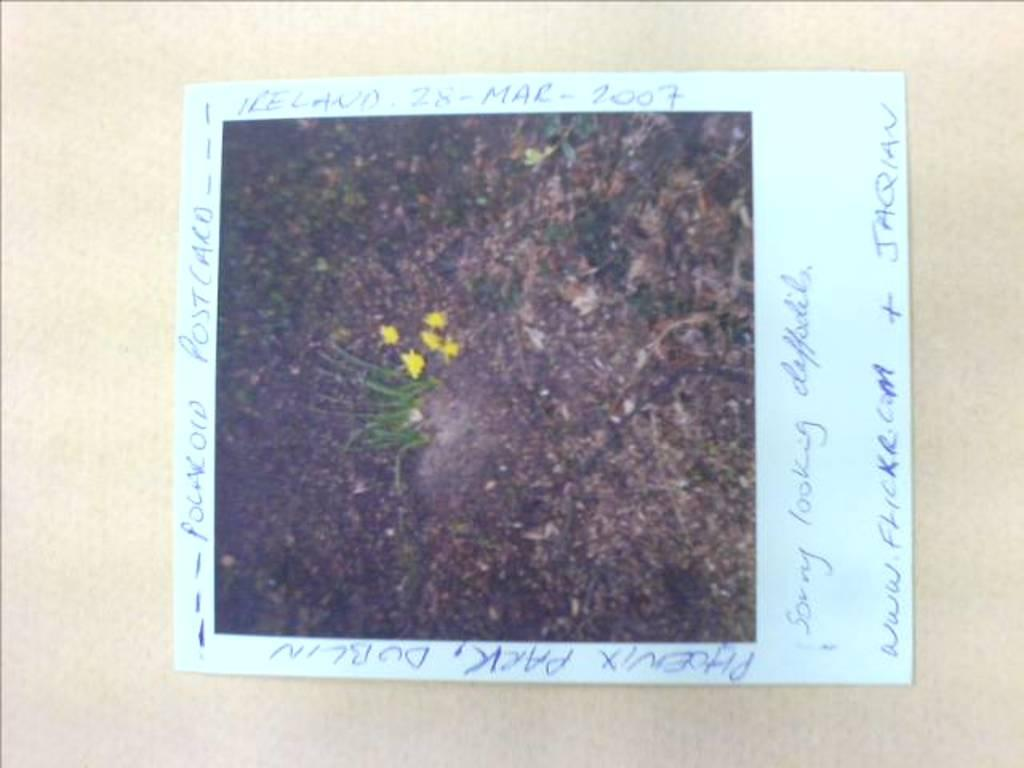What is the main subject of the paper in the image? The paper contains a picture of plants and flowers. Is there any text on the paper? Yes, there is text on the paper. What can be seen in the background of the image? The background of the image is a plane. What type of produce is being sold in the image? There is no produce being sold in the image; it features a paper with a picture of plants and flowers. Can you tell me how many fans are visible in the image? There are no fans present in the image. 